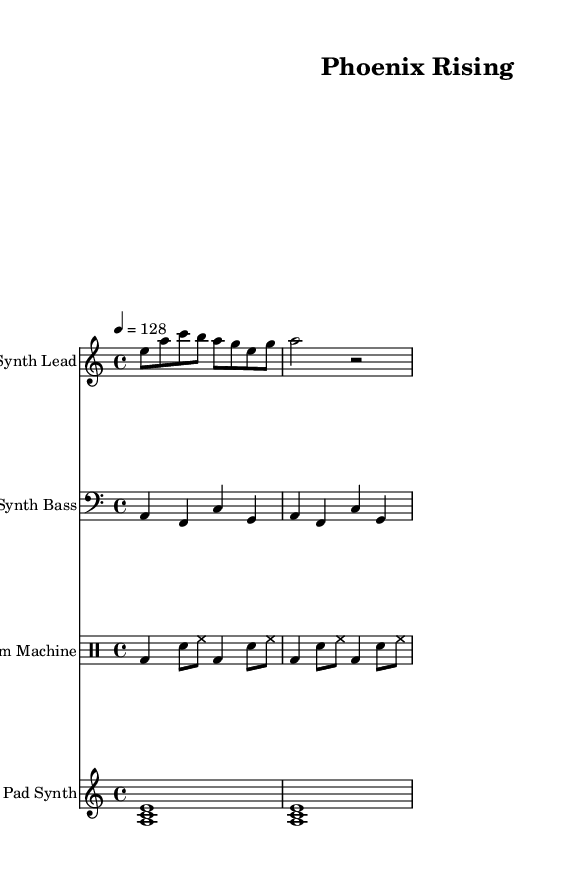What is the key signature of this music? The key signature is A minor, indicated by one sharp (C#), which is notated at the beginning of the piece.
Answer: A minor What is the time signature of this music? The time signature is 4/4, which is shown right at the beginning of the sheet music, indicating there are four beats in each measure.
Answer: 4/4 What is the tempo marking for this piece? The tempo marking indicates a speed of 128 beats per minute (BPM), shown at the start of the music.
Answer: 128 How many measures are present in the synth lead section? By counting the measures notated in the synth lead section, there are four measures visible in the shown part of the piece.
Answer: Four What is the predominant instrument used for rhythm in the piece? The rhythm is primarily driven by the drum machine, which plays a drum pattern throughout the piece, typical for electronic dance music.
Answer: Drum machine How does the introduction of synth bass compare to the lead synth in terms of frequency range? The synth bass operates in a lower frequency range, often creating a foundational groove, while the synth lead operates in a higher frequency, contributing melody and harmonic interest.
Answer: Lower frequency Which musical element emphasizes the theme of personal growth in this piece? The pad synth plays sustained chords that create a rich texture and an uplifting atmosphere, conveying themes of redemption and personal growth.
Answer: Pad synth 